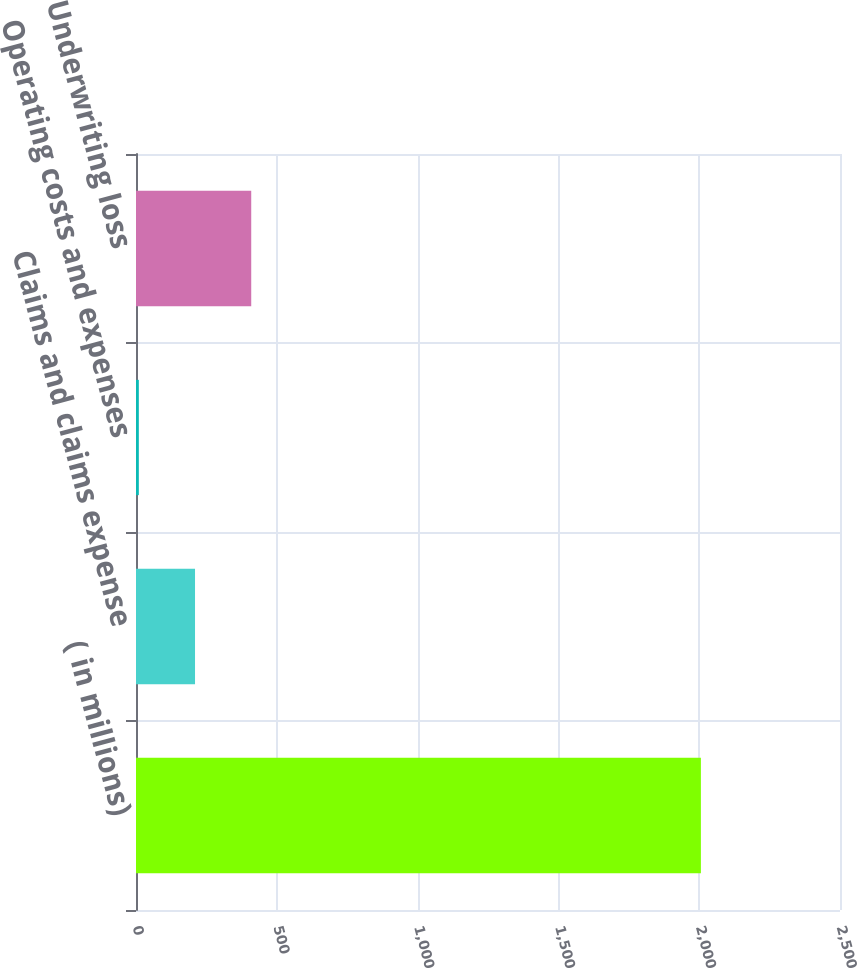Convert chart to OTSL. <chart><loc_0><loc_0><loc_500><loc_500><bar_chart><fcel>( in millions)<fcel>Claims and claims expense<fcel>Operating costs and expenses<fcel>Underwriting loss<nl><fcel>2006<fcel>209.6<fcel>10<fcel>409.2<nl></chart> 